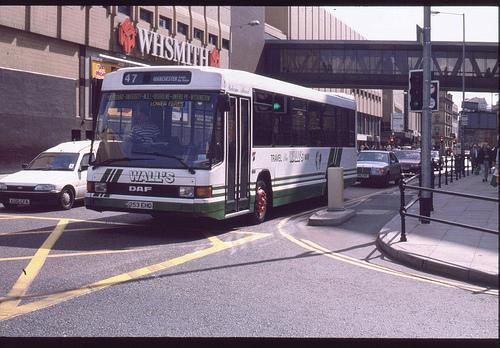How many buses are in the photo?
Give a very brief answer. 1. How many traffic lights are in the photo?
Give a very brief answer. 1. 